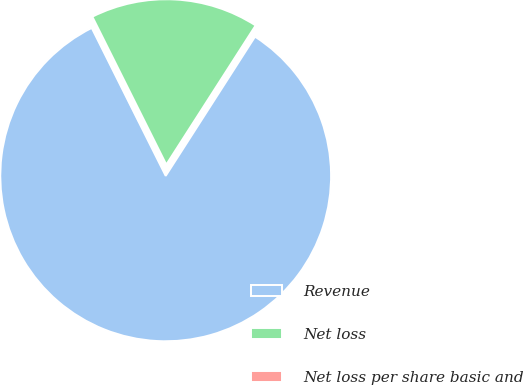Convert chart to OTSL. <chart><loc_0><loc_0><loc_500><loc_500><pie_chart><fcel>Revenue<fcel>Net loss<fcel>Net loss per share basic and<nl><fcel>83.54%<fcel>16.46%<fcel>0.0%<nl></chart> 